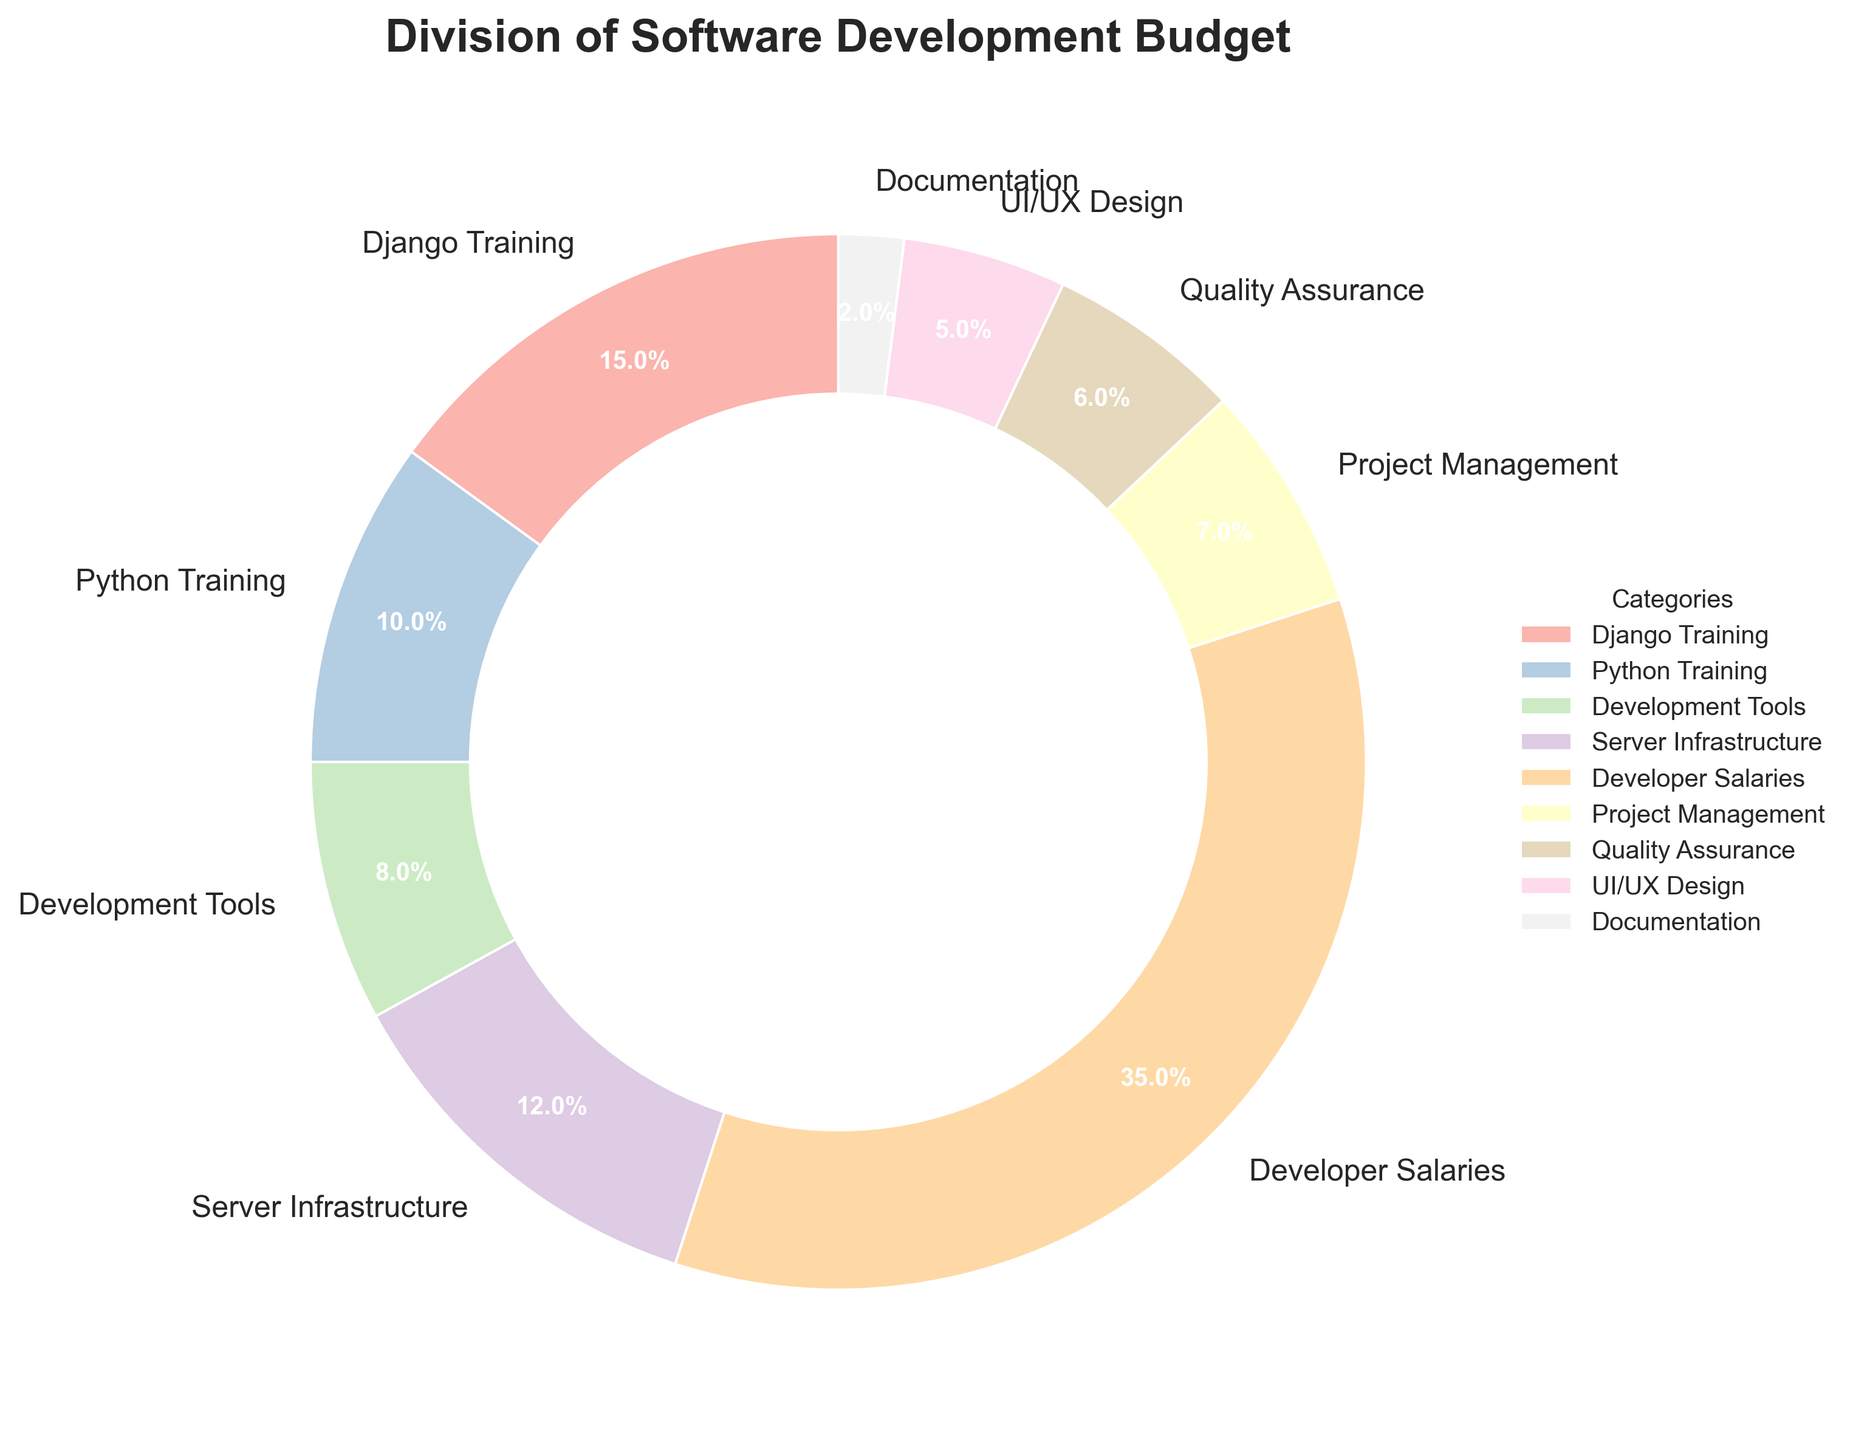Which category receives the largest portion of the budget? The largest slice of the pie chart represents the category receiving the most budget. Developer Salaries share the largest portion.
Answer: Developer Salaries What percentage of the budget is allocated to Django Training and Python Training combined? Add the percentages of Django Training and Python Training. Django Training is 15% and Python Training is 10%. Therefore, the combined percentage is 15% + 10% = 25%.
Answer: 25% How does the spending on Development Tools compare to that on Documentation? Compare the percentages of Development Tools and Documentation. Development Tools have 8%, while Documentation has 2%. 8% is greater than 2%.
Answer: Development Tools > Documentation Which categories receive less than 10% of the budget? Identify the slices of the pie chart with percentages less than 10%. These are Python Training (10%), Development Tools (8%), Project Management (7%), Quality Assurance (6%), UI/UX Design (5%), and Documentation (2%). Only UI/UX Design and Documentation are less than 10%.
Answer: Documentation, UI/UX Design, Project Management, Quality Assurance, Development Tools Is the budget for Server Infrastructure greater than the combined budget for Quality Assurance and Documentation? Compare the percentage of the budget for Server Infrastructure to the sum of Quality Assurance and Documentation. Server Infrastructure is 12%. Quality Assurance is 6%, and Documentation is 2%, so combined it is 6% + 2% = 8%. 12% is greater than 8%.
Answer: Yes Which category receives the smallest portion of the budget, and what is that percentage? The smallest slice of the pie chart represents the smallest budget allocation. Documentation has the smallest portion at 2%.
Answer: Documentation, 2% What is the total percentage allocated to Project Management, Quality Assurance, and UI/UX Design? Add the percentages of Project Management, Quality Assurance, and UI/UX Design. Project Management is 7%, Quality Assurance is 6%, and UI/UX Design is 5%. So, the total is 7% + 6% + 5% = 18%.
Answer: 18% How does spending on Developer Salaries compare to the total spending on Django Training and Server Infrastructure combined? Compare the percentage of Developer Salaries to the sum of Django Training and Server Infrastructure. Developer Salaries are 35%. Django Training is 15% and Server Infrastructure is 12%, so combined it is 15% + 12% = 27%. 35% is greater than 27%.
Answer: Developer Salaries > Django Training + Server Infrastructure Which categories have a wedge that is colored differently than the others? Visually inspect the colors of the wedges next to each other. All wedges have distinct colors.
Answer: All categories 